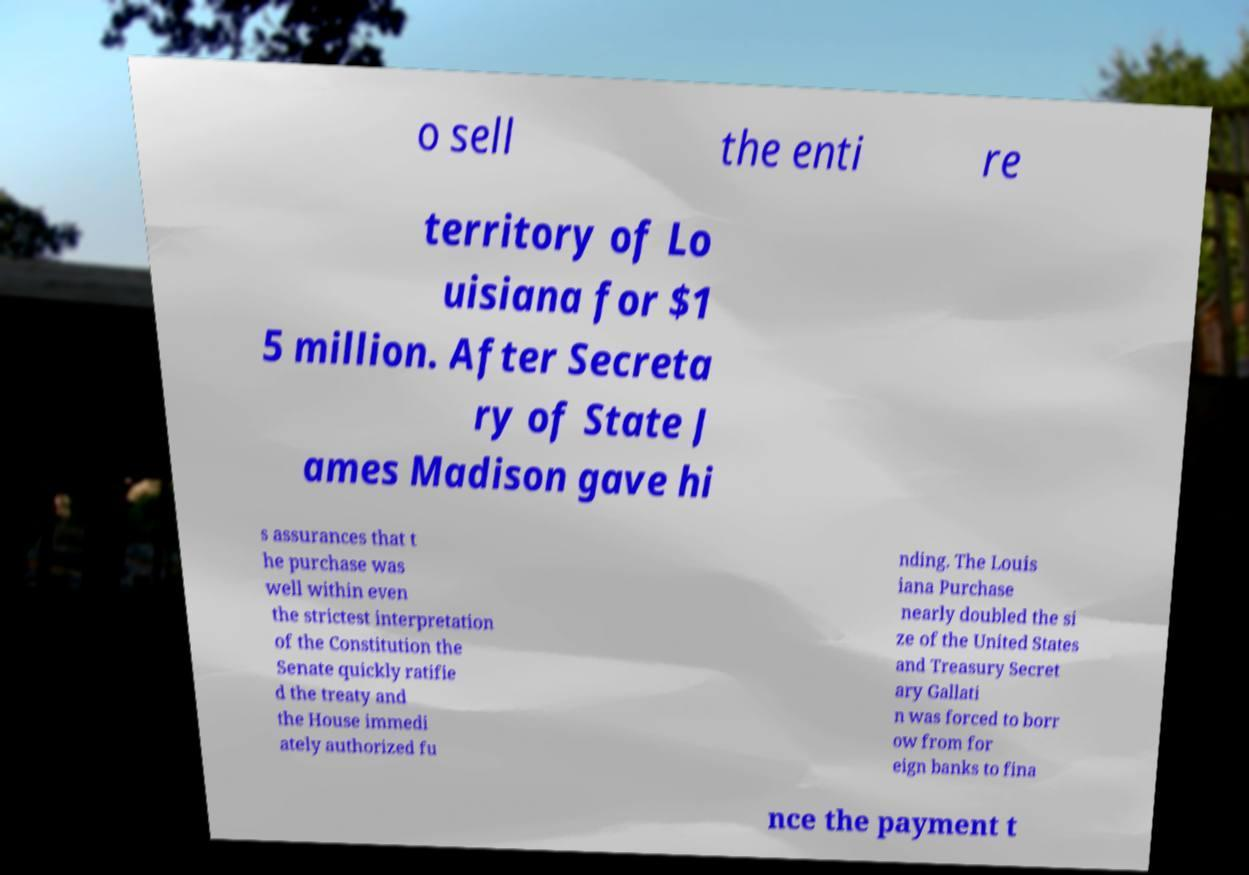I need the written content from this picture converted into text. Can you do that? o sell the enti re territory of Lo uisiana for $1 5 million. After Secreta ry of State J ames Madison gave hi s assurances that t he purchase was well within even the strictest interpretation of the Constitution the Senate quickly ratifie d the treaty and the House immedi ately authorized fu nding. The Louis iana Purchase nearly doubled the si ze of the United States and Treasury Secret ary Gallati n was forced to borr ow from for eign banks to fina nce the payment t 